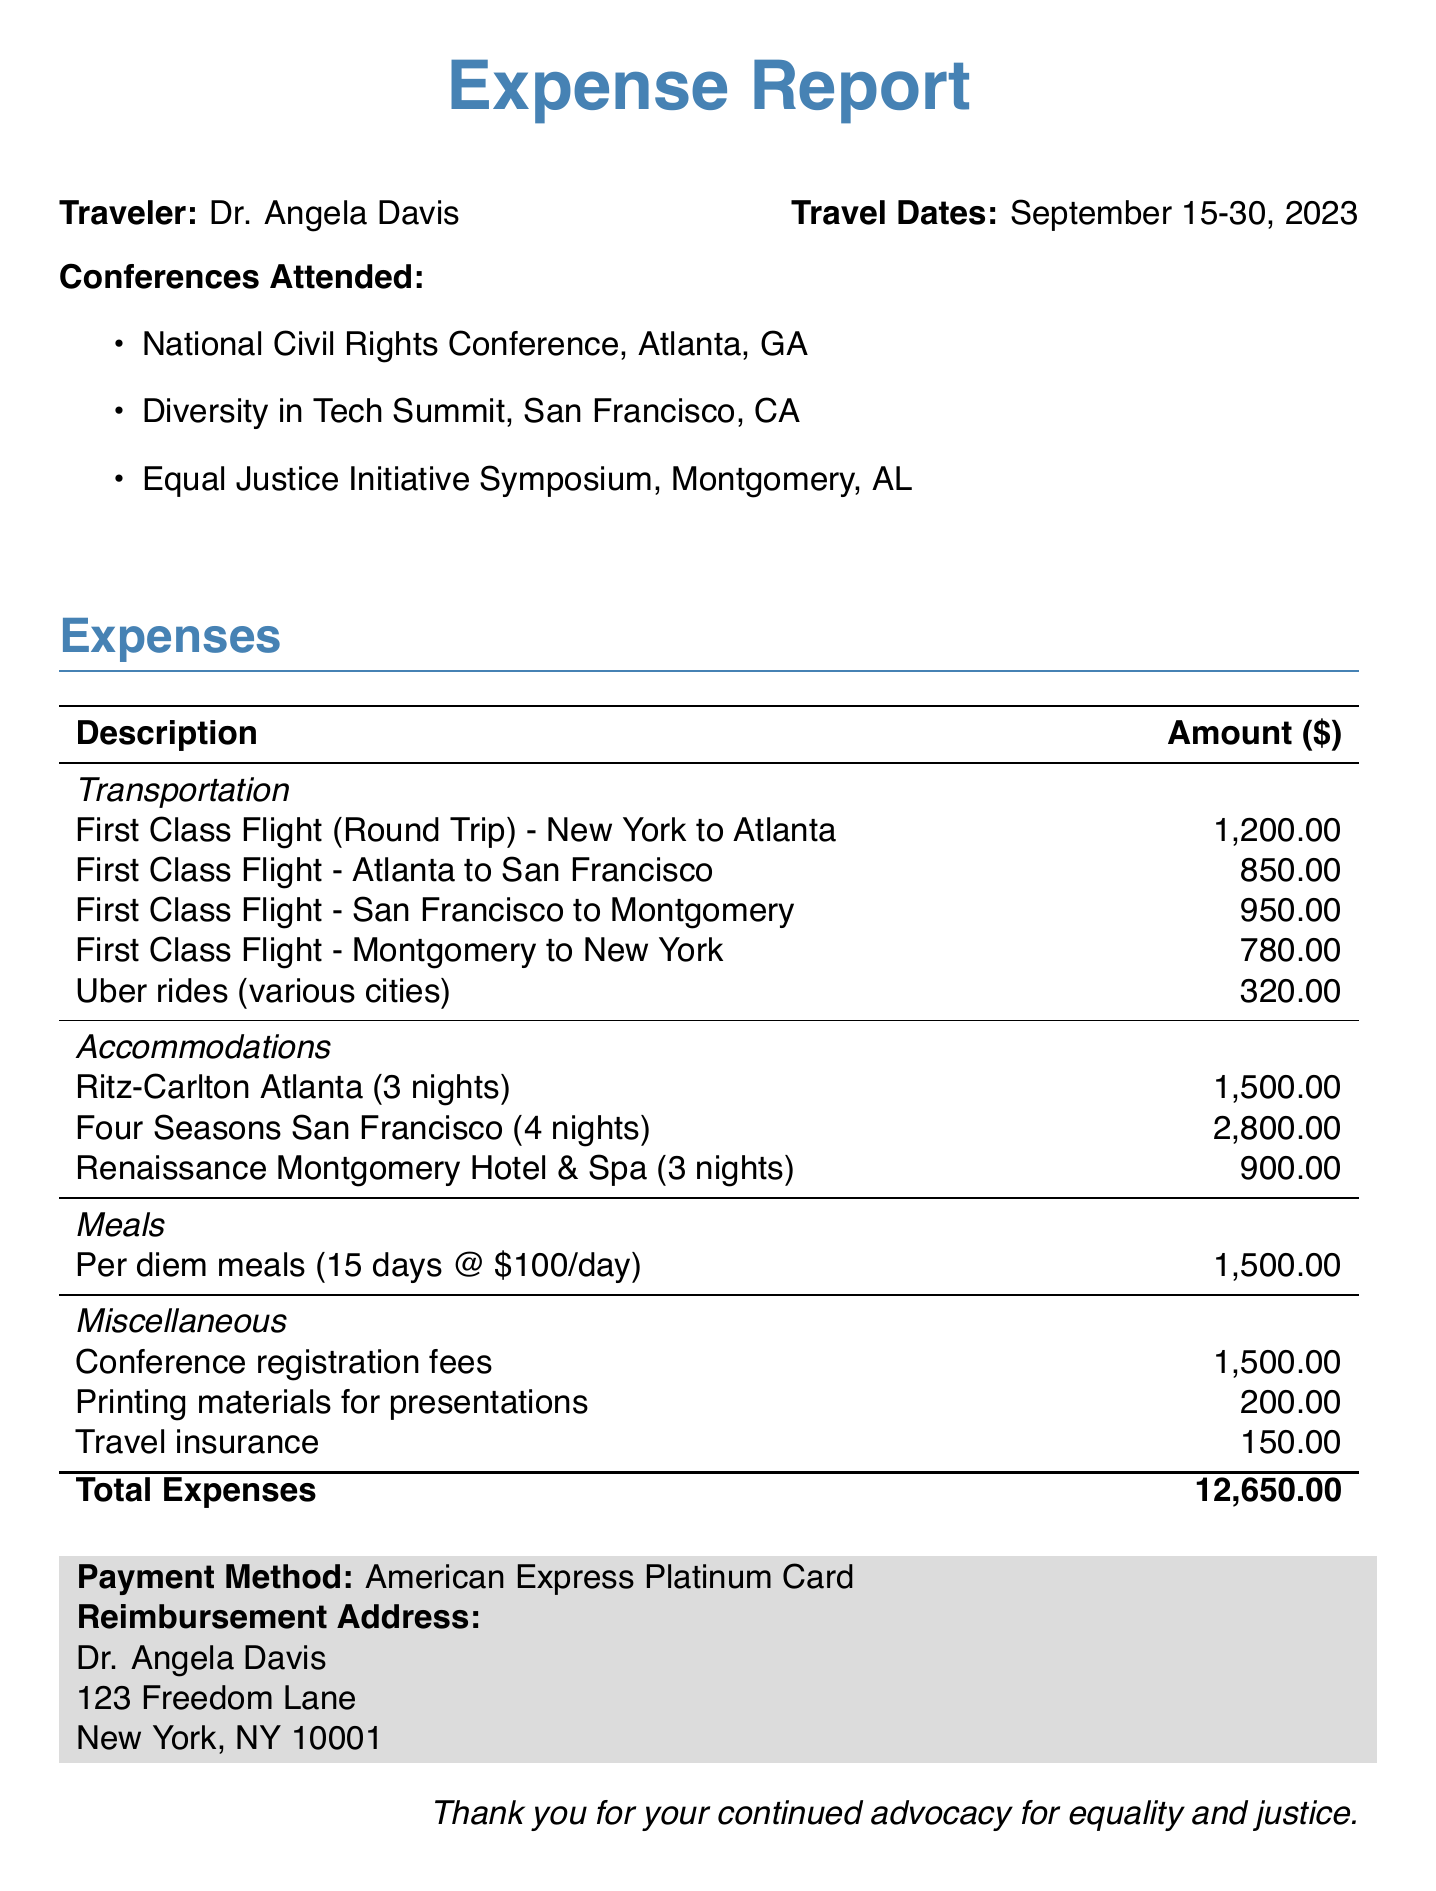What is the traveler's name? The traveler's name is mentioned at the beginning of the document as Dr. Angela Davis.
Answer: Dr. Angela Davis What are the travel dates? The travel dates are specified directly in the document, showing the start and end dates of the travel.
Answer: September 15-30, 2023 How many nights did the traveler stay at the Ritz-Carlton Atlanta? The number of nights is provided in the accommodations section under Ritz-Carlton Atlanta.
Answer: 3 nights What is the total amount of expenses? The total expenses is calculated by summing all listed expenses and is clearly stated at the end of the expenses section.
Answer: 12,650.00 How much was spent on Uber rides? The amount spent on Uber rides is outlined in the transportation section of the expenses.
Answer: 320.00 How many conferences did the traveler attend? The number of conferences attended is listed in the document outlined in the conferences attended section.
Answer: 3 What method of payment was used for the expenses? The payment method is mentioned at the bottom of the expenses document stating the type of card used.
Answer: American Express Platinum Card What accommodations were made in San Francisco? The accommodations for San Francisco are detailed in the accommodations section specifically mentioning the hotel name.
Answer: Four Seasons San Francisco What was the total cost for per diem meals? The cost for per diem meals is indicated, showing how many days were accounted for and the daily rate used for calculations.
Answer: 1,500.00 